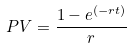Convert formula to latex. <formula><loc_0><loc_0><loc_500><loc_500>P V = \frac { 1 - e ^ { ( - r t ) } } { r }</formula> 